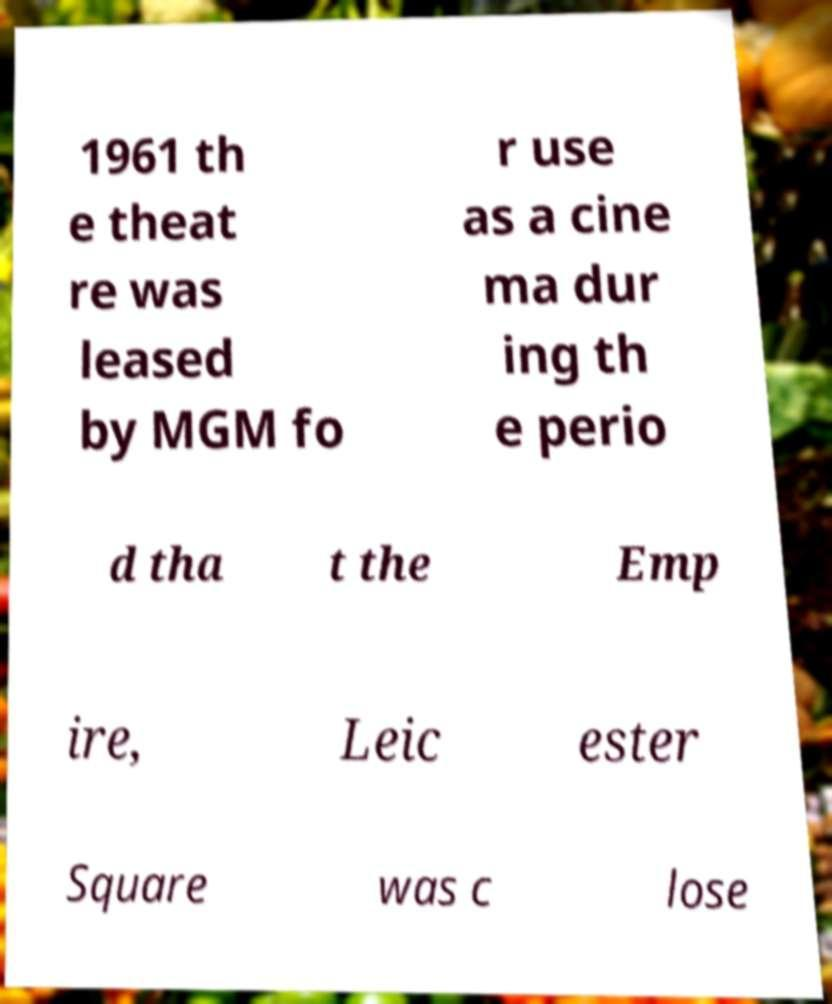Can you accurately transcribe the text from the provided image for me? 1961 th e theat re was leased by MGM fo r use as a cine ma dur ing th e perio d tha t the Emp ire, Leic ester Square was c lose 